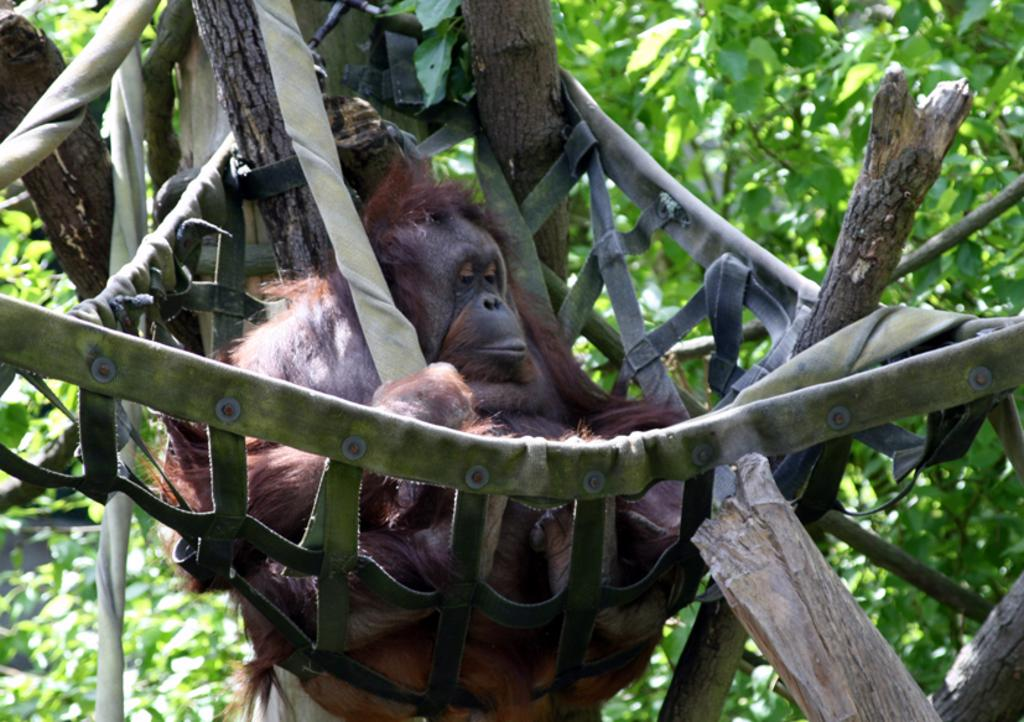What type of animal is in the image? There is a brown color chimpanzee in the image. What is the chimpanzee doing in the image? The chimpanzee is laying in a swing. How is the swing supported in the image? The swing is tied to trees. What can be seen in the background of the image? There are trees in the background of the image. What type of underwear is the chimpanzee wearing in the image? The chimpanzee is not wearing any underwear in the image. Can you describe the furniture in the image? There is no furniture present in the image; it features a chimpanzee in a swing tied to trees. 